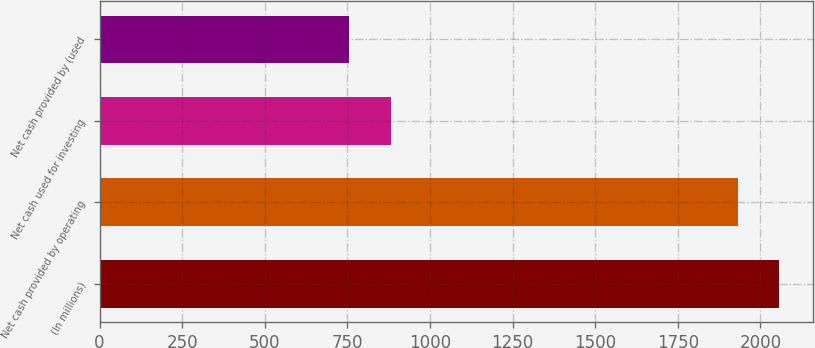Convert chart to OTSL. <chart><loc_0><loc_0><loc_500><loc_500><bar_chart><fcel>(In millions)<fcel>Net cash provided by operating<fcel>Net cash used for investing<fcel>Net cash provided by (used<nl><fcel>2057.49<fcel>1931.2<fcel>881.39<fcel>755.1<nl></chart> 